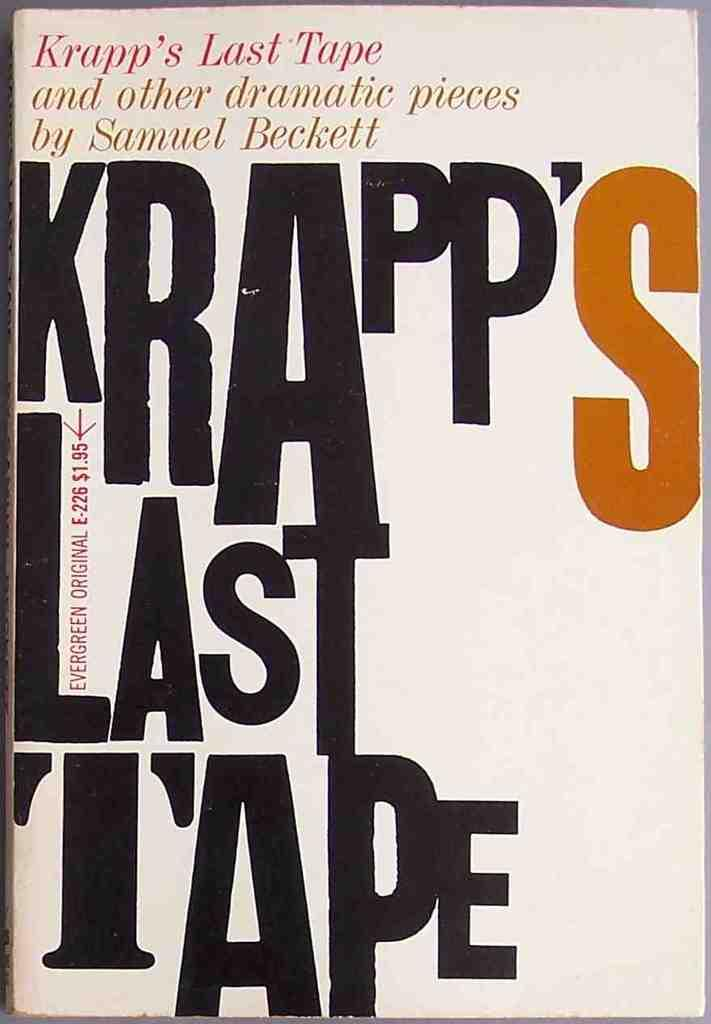<image>
Give a short and clear explanation of the subsequent image. The cover for Krapp's Last tape by Samuel Beckett 